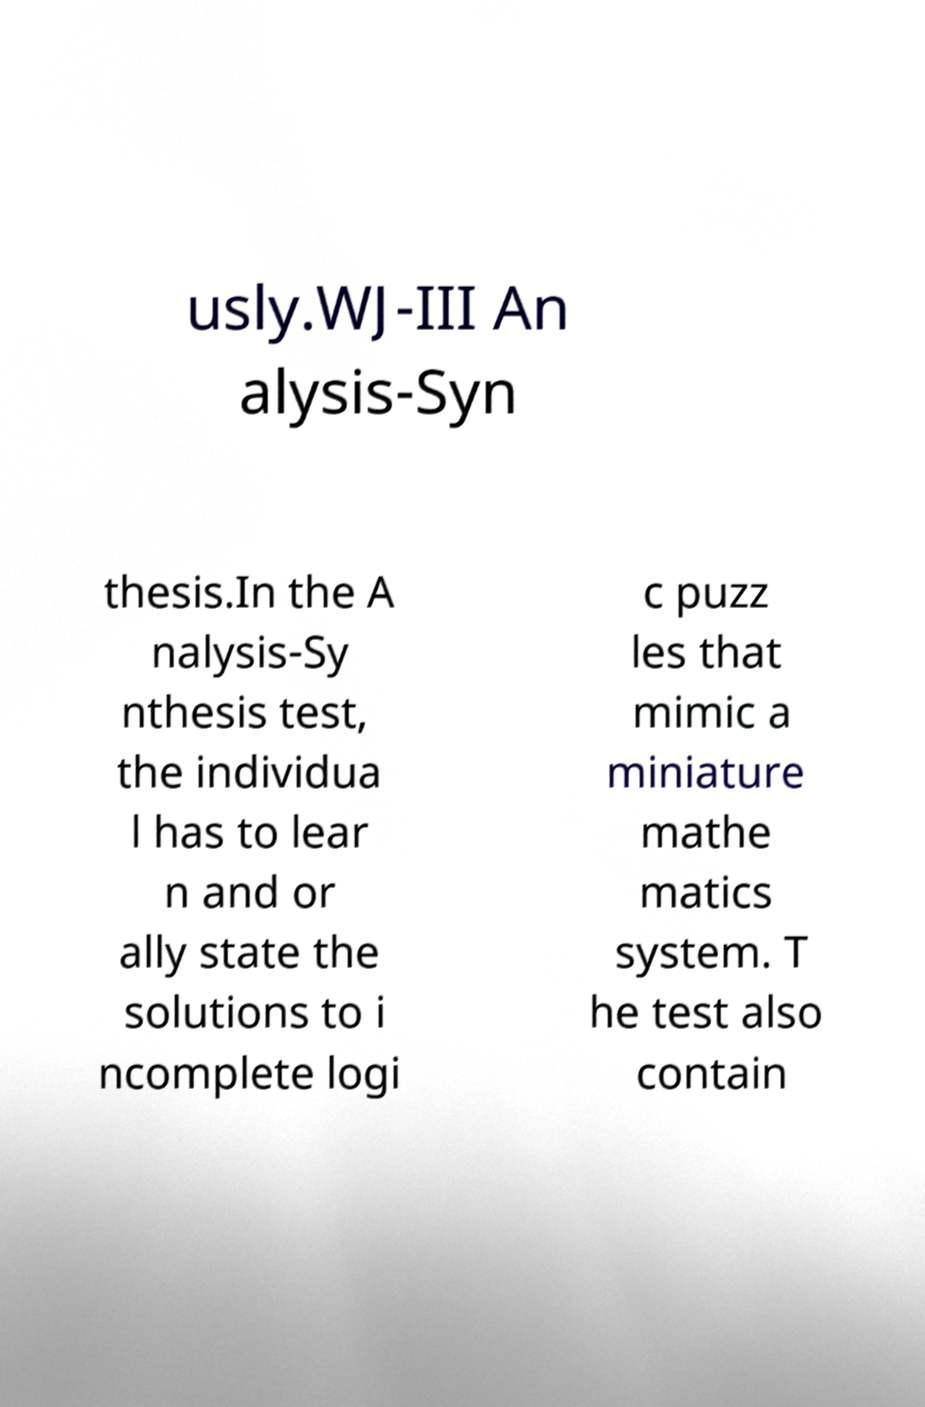For documentation purposes, I need the text within this image transcribed. Could you provide that? usly.WJ-III An alysis-Syn thesis.In the A nalysis-Sy nthesis test, the individua l has to lear n and or ally state the solutions to i ncomplete logi c puzz les that mimic a miniature mathe matics system. T he test also contain 